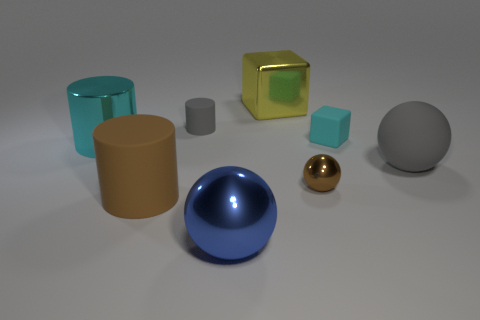Add 2 big brown shiny spheres. How many objects exist? 10 Subtract all cylinders. How many objects are left? 5 Subtract 0 red cylinders. How many objects are left? 8 Subtract all big blue balls. Subtract all small brown metal objects. How many objects are left? 6 Add 7 blue metallic things. How many blue metallic things are left? 8 Add 6 tiny red metal cylinders. How many tiny red metal cylinders exist? 6 